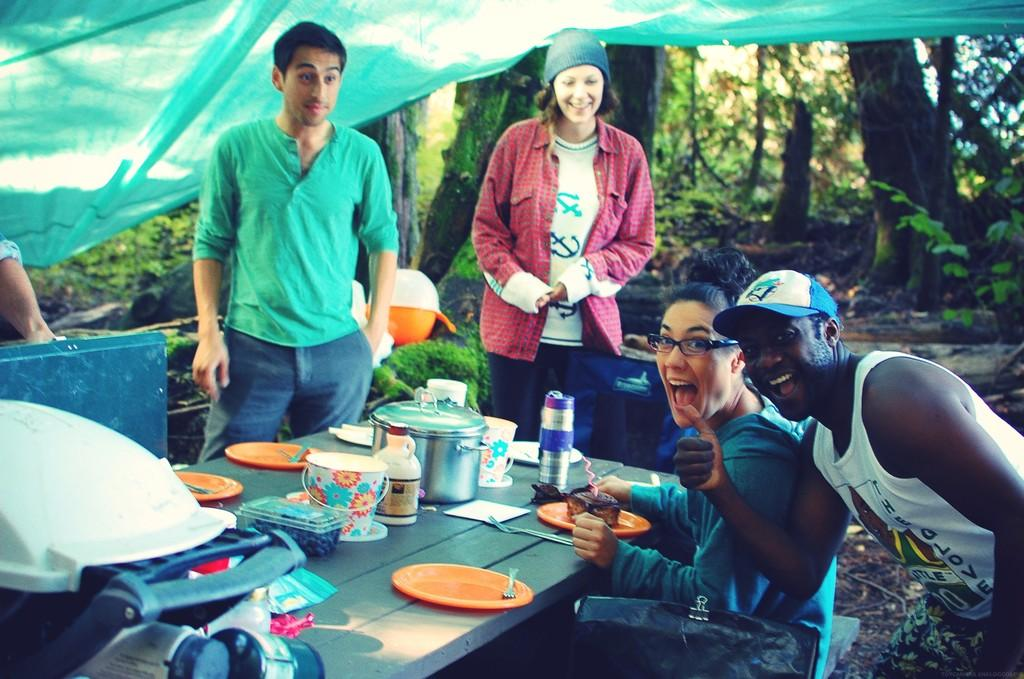How many people are present in the image? There are four people in the image, three standing and one sitting. What objects are on the table in the image? There is a bucket, a plate, a fork, a bottle, a bowl, and a tissue on the table. What can be seen in the background of the image? There are trees and a tent in the background of the image. What type of wing is visible on the person sitting in the image? There are no wings visible on any of the persons in the image. Can you tell me how many keys are on the table in the image? There are no keys present on the table in the image. 